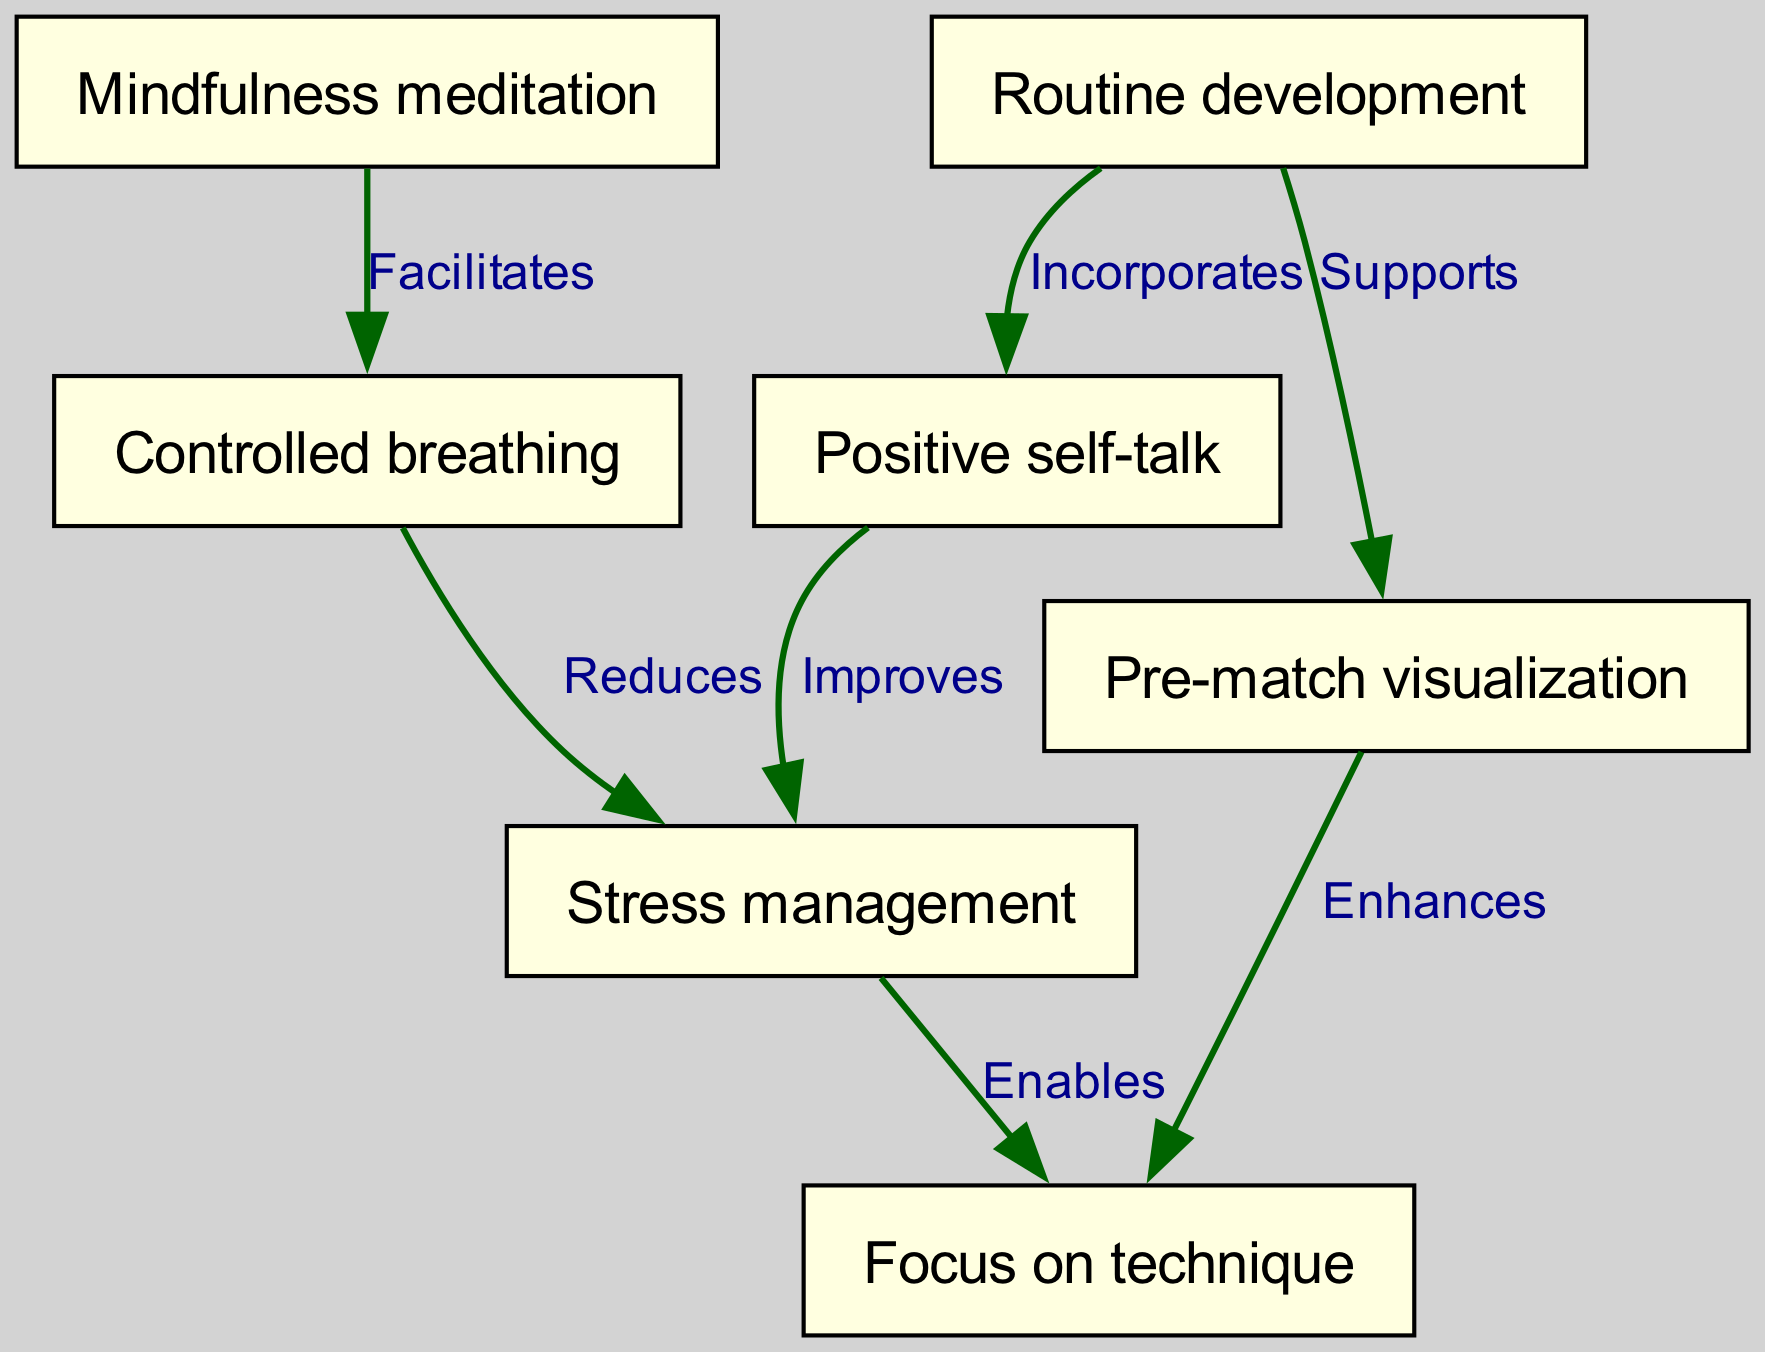What's the total number of nodes in the diagram? To find the total number of nodes, I count each distinct item listed in the "nodes" section of the data. The nodes are: Pre-match visualization, Controlled breathing, Positive self-talk, Routine development, Focus on technique, Mindfulness meditation, and Stress management. There are 7 nodes in total.
Answer: 7 What edge connects "Pre-match visualization" and "Focus on technique"? The directed graph shows an edge that starts from "Pre-match visualization" and points to "Focus on technique". The label on this edge indicates that "Pre-match visualization" enhances "Focus on technique".
Answer: Enhances Which technique facilitates controlled breathing? The edge coming from "Mindfulness meditation" to "Controlled breathing" suggests that mindfulness meditation facilitates controlled breathing. This is noted by the label on the edge.
Answer: Mindfulness meditation How many edges are there in the graph? By counting the entries in the "edges" section of the data, which lists the links between different nodes, I see that there are 7 edges connecting the nodes.
Answer: 7 Which techniques are indicated as having a direct relationship with stress management? To find the techniques that have a direct relationship with stress management, I look for all edges directed towards "Stress management". I see two edges: one from "Controlled breathing" labeled "Reduces" and another from "Positive self-talk" labeled "Improves".
Answer: Controlled breathing, Positive self-talk What does "Routine development" support in this diagram? The edge from "Routine development" to "Pre-match visualization" indicates that "Routine development" supports "Pre-match visualization". This is directly stated in the label on the edge.
Answer: Pre-match visualization If "Stress management" is improved, what technique can be enhanced as a result? The edge from "Stress management" to "Focus on technique" indicates that when stress management improves, it enables a better focus on technique. Therefore, if stress management is improved, "Focus on technique" can be enhanced.
Answer: Focus on technique Which two techniques are incorporated by "Routine development"? From examining the diagram, I can see that "Routine development" has edges directed towards both "Pre-match visualization" and "Positive self-talk", indicating that it incorporates both of these techniques.
Answer: Pre-match visualization, Positive self-talk 